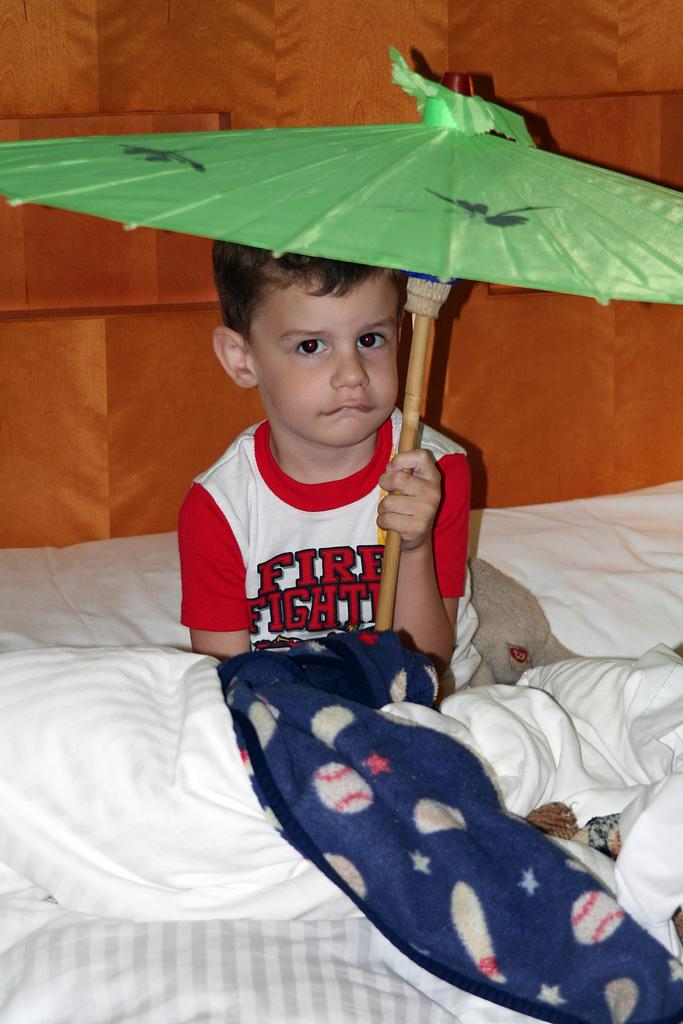Who is the main subject in the image? There is a boy in the image. What is the boy doing in the image? The boy is sitting on the bed. What object is the boy holding in the image? The boy is holding a green-colored umbrella. What is covering the bottom part of the bed? There are blankets at the bottom of the bed. Are there any plastic ducks visible in the image? No, there are no plastic ducks present in the image. 